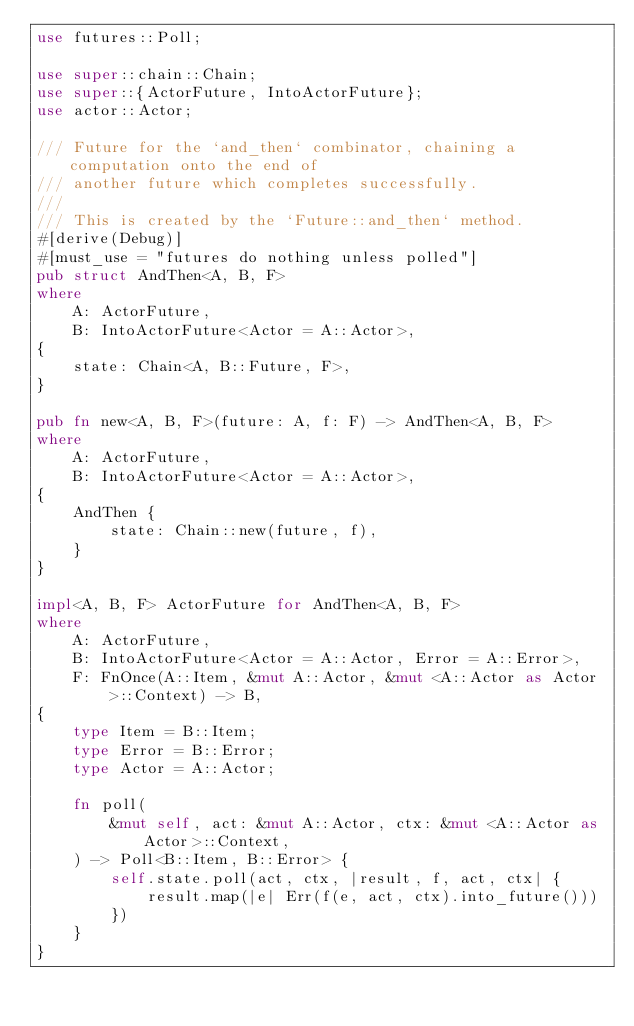Convert code to text. <code><loc_0><loc_0><loc_500><loc_500><_Rust_>use futures::Poll;

use super::chain::Chain;
use super::{ActorFuture, IntoActorFuture};
use actor::Actor;

/// Future for the `and_then` combinator, chaining a computation onto the end of
/// another future which completes successfully.
///
/// This is created by the `Future::and_then` method.
#[derive(Debug)]
#[must_use = "futures do nothing unless polled"]
pub struct AndThen<A, B, F>
where
    A: ActorFuture,
    B: IntoActorFuture<Actor = A::Actor>,
{
    state: Chain<A, B::Future, F>,
}

pub fn new<A, B, F>(future: A, f: F) -> AndThen<A, B, F>
where
    A: ActorFuture,
    B: IntoActorFuture<Actor = A::Actor>,
{
    AndThen {
        state: Chain::new(future, f),
    }
}

impl<A, B, F> ActorFuture for AndThen<A, B, F>
where
    A: ActorFuture,
    B: IntoActorFuture<Actor = A::Actor, Error = A::Error>,
    F: FnOnce(A::Item, &mut A::Actor, &mut <A::Actor as Actor>::Context) -> B,
{
    type Item = B::Item;
    type Error = B::Error;
    type Actor = A::Actor;

    fn poll(
        &mut self, act: &mut A::Actor, ctx: &mut <A::Actor as Actor>::Context,
    ) -> Poll<B::Item, B::Error> {
        self.state.poll(act, ctx, |result, f, act, ctx| {
            result.map(|e| Err(f(e, act, ctx).into_future()))
        })
    }
}
</code> 